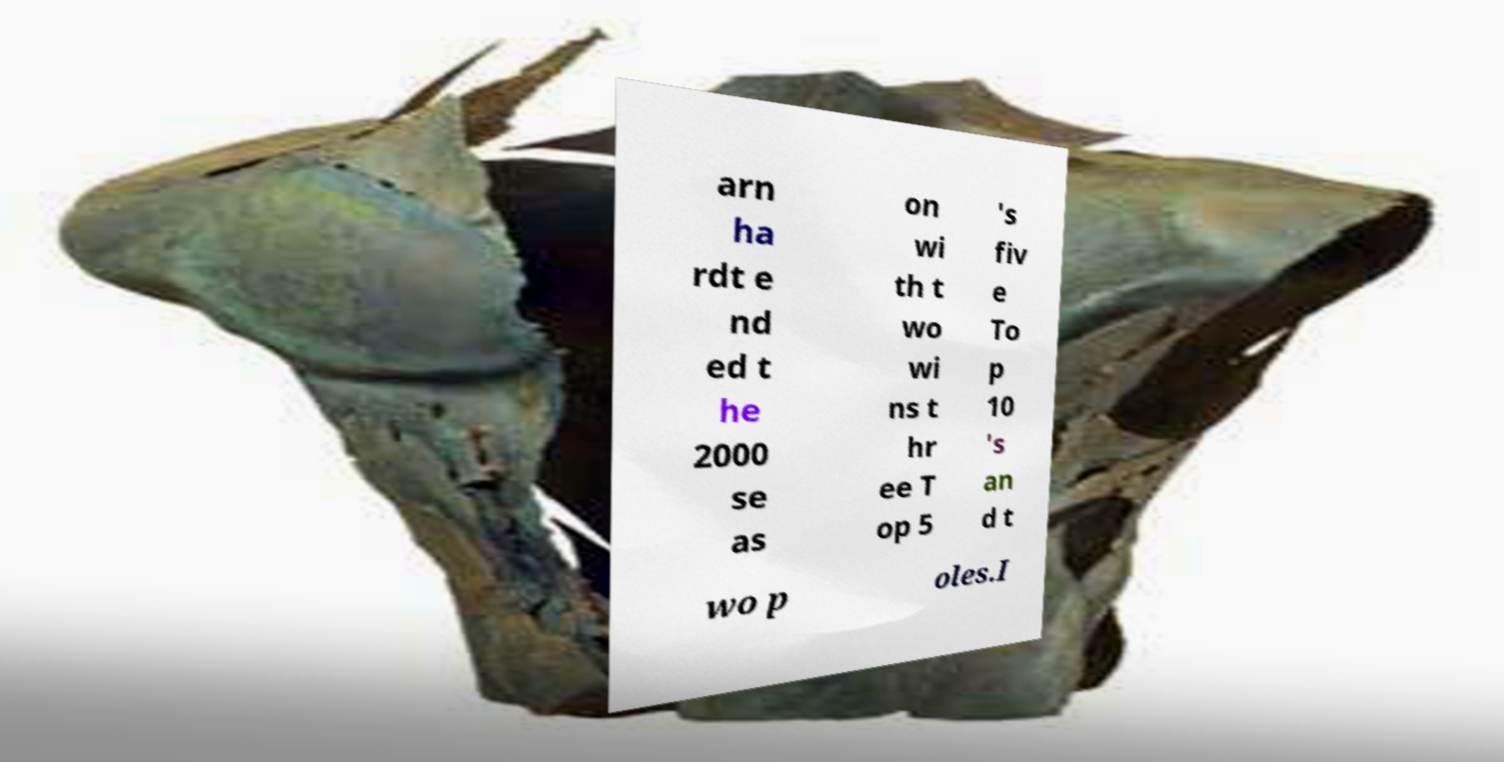Can you accurately transcribe the text from the provided image for me? arn ha rdt e nd ed t he 2000 se as on wi th t wo wi ns t hr ee T op 5 's fiv e To p 10 's an d t wo p oles.I 